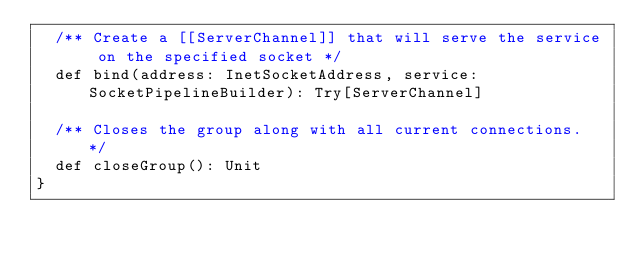<code> <loc_0><loc_0><loc_500><loc_500><_Scala_>  /** Create a [[ServerChannel]] that will serve the service on the specified socket */
  def bind(address: InetSocketAddress, service: SocketPipelineBuilder): Try[ServerChannel]

  /** Closes the group along with all current connections. */
  def closeGroup(): Unit
}
</code> 